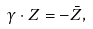<formula> <loc_0><loc_0><loc_500><loc_500>\gamma \cdot Z = - \bar { Z } ,</formula> 